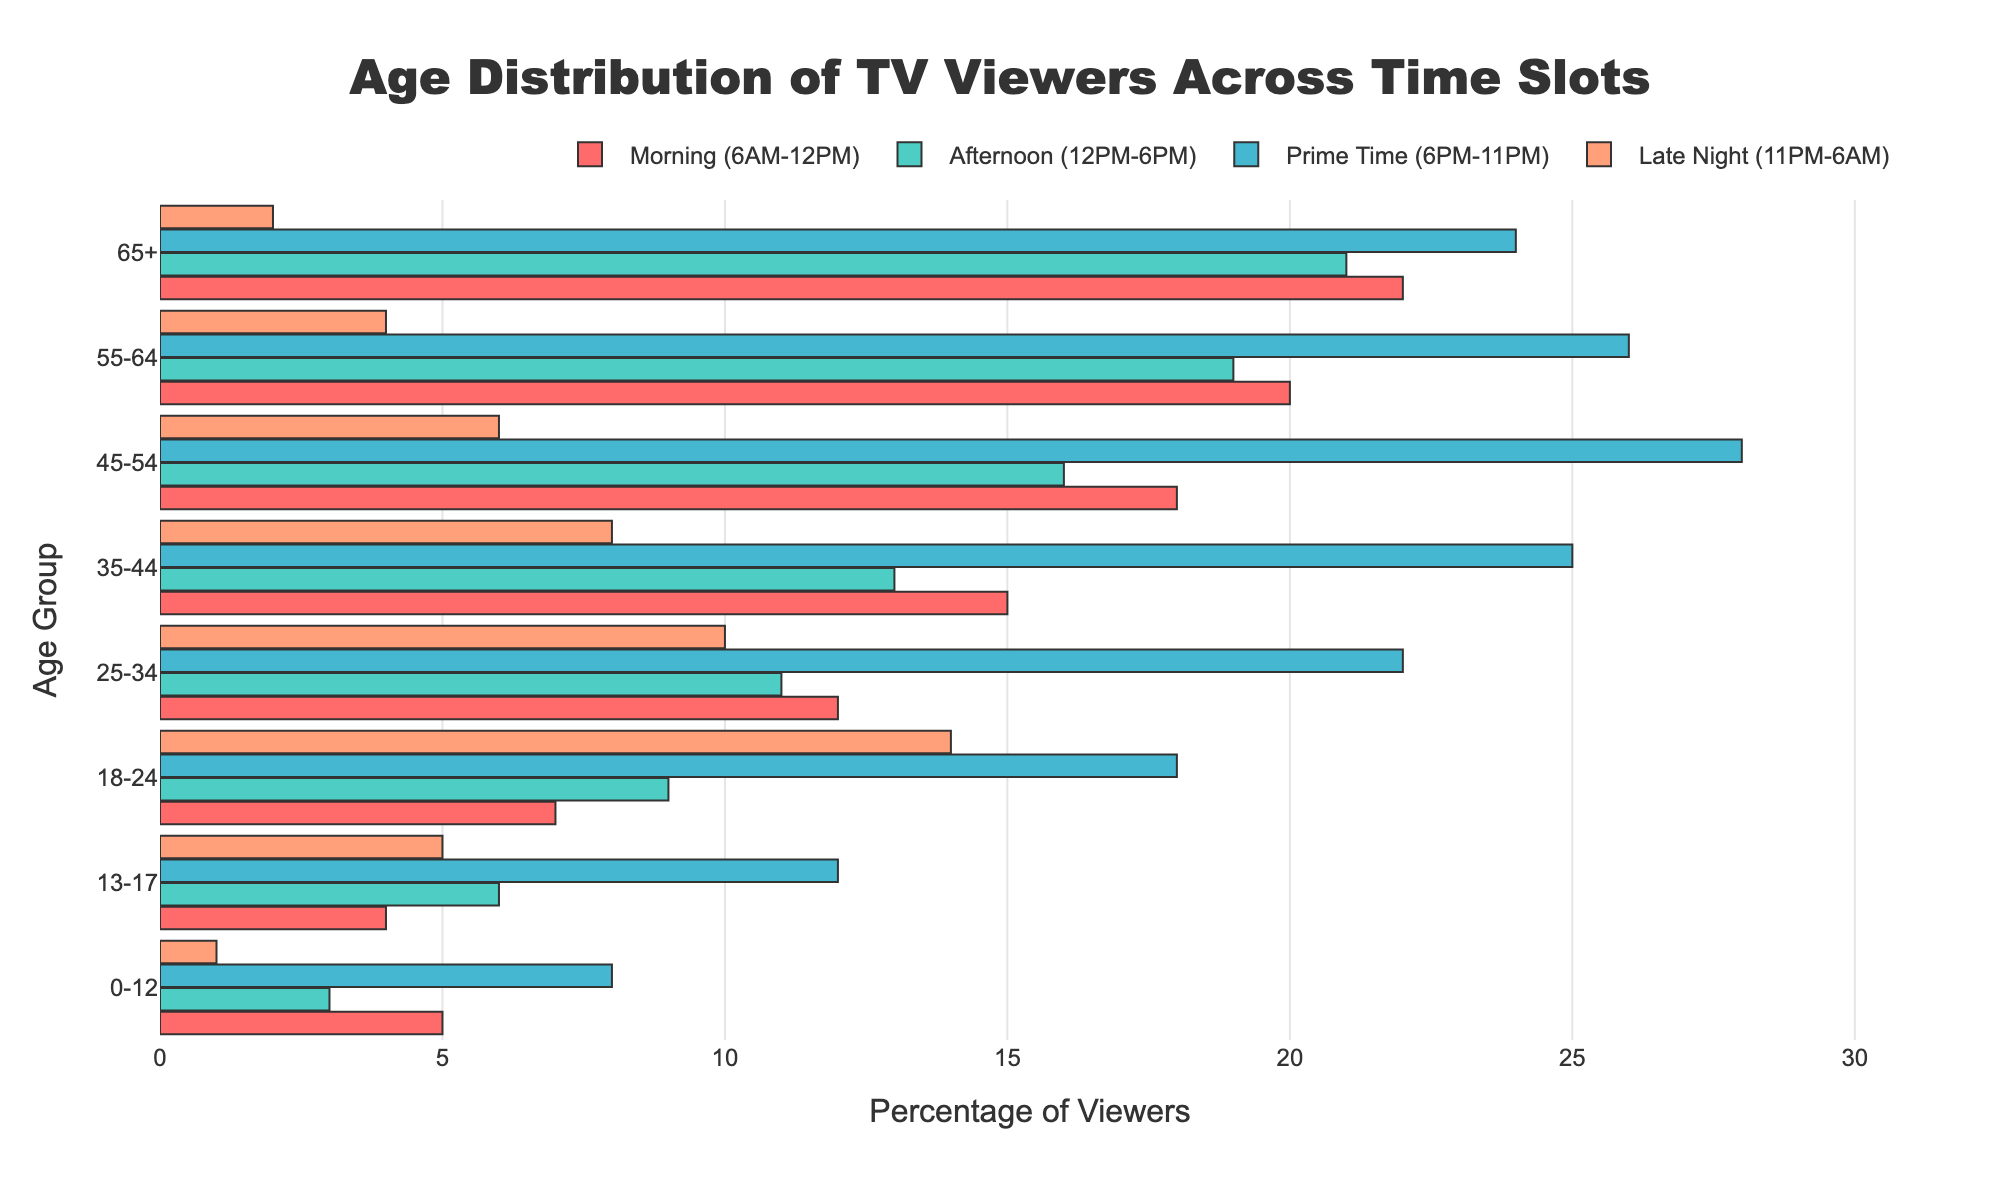what is the title of the figure? The title is generally found at the top of the figure and usually gives an overview of what the figure is about.
Answer: Age Distribution of TV Viewers Across Time Slots Which age group has the highest percentage of viewers in the morning slot? To find the answer, locate the highest bar in the morning slot section, which corresponds to the different age groups.
Answer: 65+ What is the combined percentage of viewers aged 0-12 during Prime Time and Late Night? Combine the Prime Time value (8) and the Late Night value (1) for this age group to get the total.
Answer: 9 In which time slot do viewers aged 18-24 watch the most TV? Identify the largest bar for the age group 18-24 across all time slots.
Answer: Prime Time How does the percentage of viewers aged 55-64 in the Late Night slot compare to those aged 45-54? Compare the Late Night values for these two age groups (4 for 55-64 and 6 for 45-54). The group with the higher value watches more TV in that slot.
Answer: Less What is the average percentage of viewers aged 35-44 across all time slots? Calculate the sum of percentages for this age group (15 + 13 + 25 + 8) and then divide by the number of time slots (4).
Answer: 15.25 Which time slot has the most balanced age distribution? The most balanced age distribution would imply relatively even bars across the different age groups. Compare the uniformity of bars in each time slot.
Answer: Afternoon What is the age group with the smallest number of viewers in the Late Night slot? Locate the smallest bar in the Late Night section of the plot which corresponds to the different age groups.
Answer: 65+ How many age groups have more than 10% viewers in the Prime Time slot? Identify the bars in the Prime Time slot greater than 10% and count them.
Answer: 4 Which age group has the largest increase in viewership from the Morning slot to the Prime Time slot? Calculate the difference in viewership percentages between Prime Time and Morning for each age group, then identify the age group with the largest increase (Prime Time % - Morning %).
Answer: 18-24 